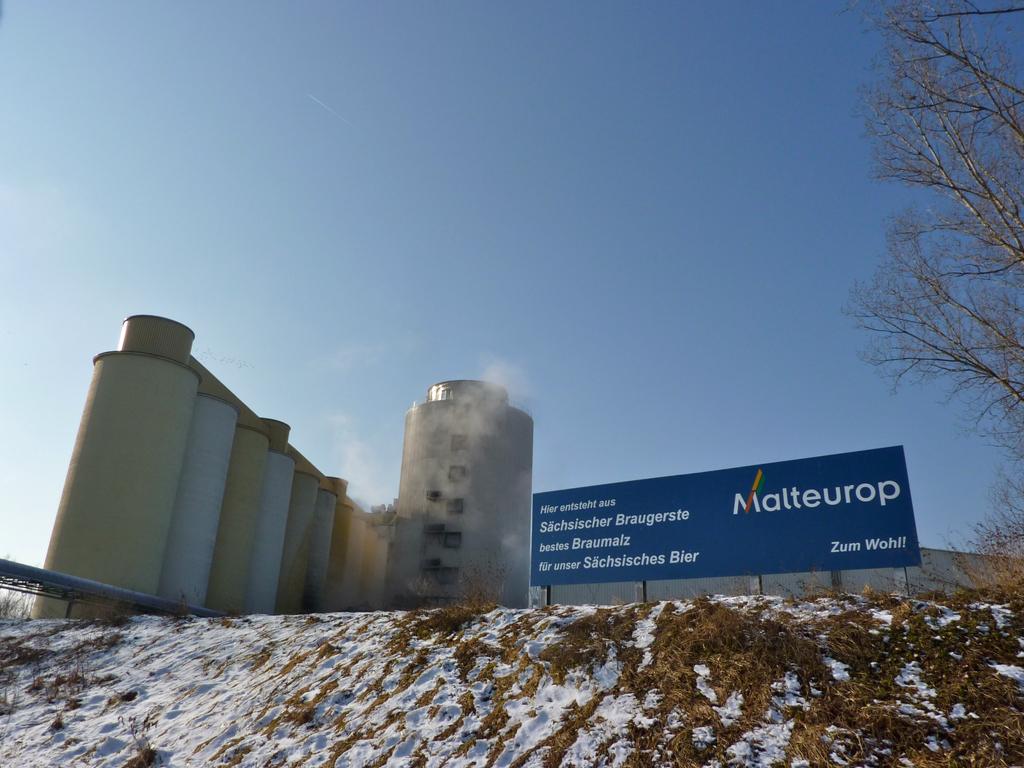What is the name of the company?
Provide a succinct answer. Malteurop. Who is sponsoring this company? (name bottom right)?
Your response must be concise. Zum wohl. 